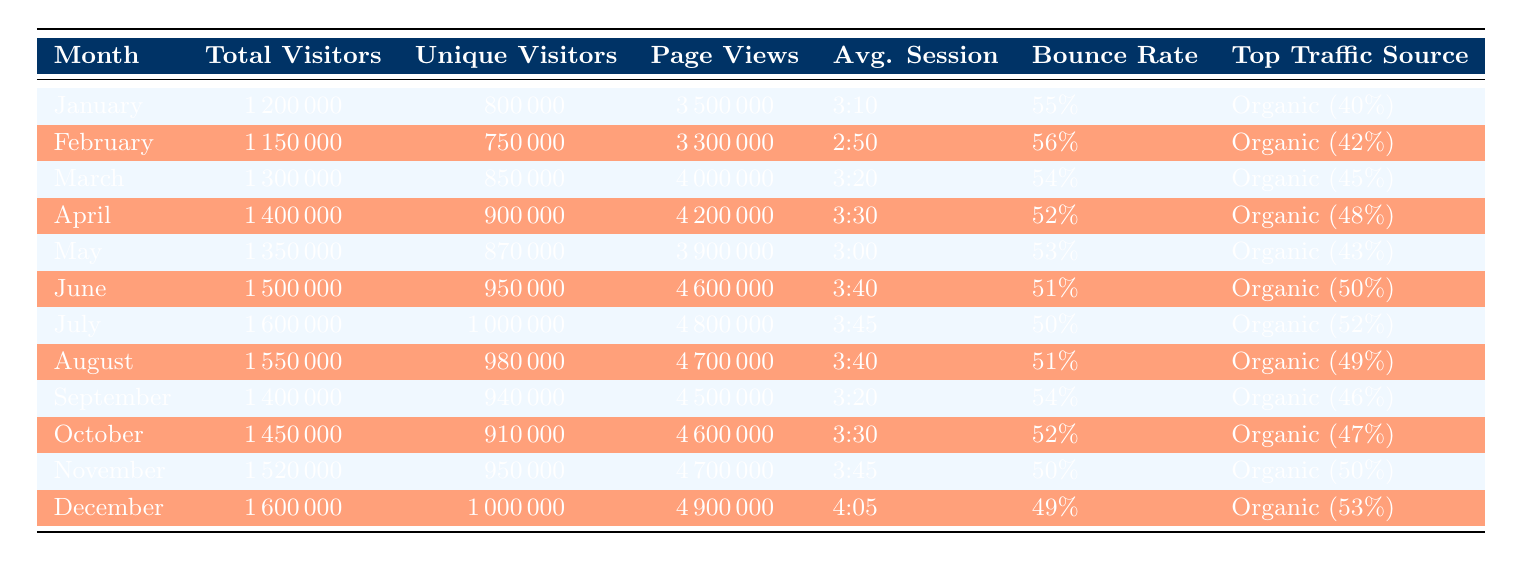What is the total number of visitors in July? The table provides the total visitors for each month. Looking at the row for July, the total visitors is listed as 1,600,000.
Answer: 1,600,000 What was the average session duration in December? To find this, we look at the December row in the table. The average session duration is explicitly listed as 4:05.
Answer: 4:05 Which month had the highest bounce rate, and what was it? We need to check the bounce rate values for each month. Scanning through the table, February has the highest bounce rate at 56%.
Answer: February, 56% What is the total number of page views for the entire year? We sum the page views for each month: 3,500,000 (Jan) + 3,300,000 (Feb) + 4,000,000 (Mar) + 4,200,000 (Apr) + 3,900,000 (May) + 4,600,000 (Jun) + 4,800,000 (Jul) + 4,700,000 (Aug) + 4,500,000 (Sep) + 4,600,000 (Oct) + 4,700,000 (Nov) + 4,900,000 (Dec) = 56,000,000.
Answer: 56,000,000 Did the unique visitors increase from April to May? Checking the unique visitors for these months shows April had 900,000 and May had 870,000. Since 870,000 is less than 900,000, the number did not increase.
Answer: No What is the average bounce rate across all months? To calculate this, we sum the bounce rates for all months: 55% + 56% + 54% + 52% + 53% + 51% + 50% + 51% + 54% + 52% + 50% + 49% = 621%. Then we divide by the number of months (12): 621% / 12 = 51.75%.
Answer: 51.75% Which month had the most unique visitors? By examining the unique visitors column across all months, July shows the highest figure of 1,000,000 unique visitors.
Answer: July, 1,000,000 What percentage of traffic for June was organic? In the June row, the organic traffic is listed as 50%. Therefore, the percentage of traffic that was organic in June is 50%.
Answer: 50% How does the total visitor count for December compare to that for January? Comparing the total visitors: December has 1,600,000 and January has 1,200,000. Since 1,600,000 is greater than 1,200,000, December has more visitors.
Answer: December is higher 